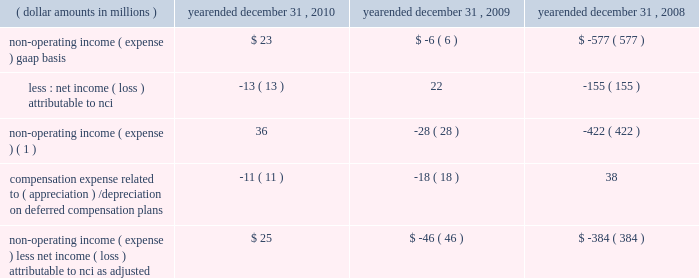4 4 m a n a g e m e n t 2019 s d i s c u s s i o n notes to table ( continued ) ( a ) ( continued ) management believes that operating income , as adjusted , and operating margin , as adjusted , are effective indicators of blackrock 2019s financial performance over time .
As such , management believes that operating income , as adjusted , and operating margin , as adjusted , provide useful disclosure to investors .
Operating income , as adjusted : bgi transaction and integration costs recorded in 2010 and 2009 consist principally of certain advisory payments , compensation expense , legal fees , marketing and promotional , occupancy and consulting expenses incurred in conjunction with the bgi transaction .
Restructuring charges recorded in 2009 and 2008 consist of compensation costs , occupancy costs and professional fees .
The expenses associated with restructuring and bgi transaction and integration costs have been deemed non-recurring by management and have been excluded from operating income , as adjusted , to help enhance the comparability of this information to the current reporting periods .
As such , management believes that operating margins exclusive of these costs are useful measures in evaluating blackrock 2019s operating performance for the respective periods .
The portion of compensation expense associated with certain long-term incentive plans ( 201cltip 201d ) that will be funded through the distribution to participants of shares of blackrock stock held by pnc and a merrill lynch cash compensation contribution , a portion of which has been received , have been excluded because these charges ultimately do not impact blackrock 2019s book value .
Compensation expense associated with appreciation/ ( depreciation ) on investments related to certain blackrock deferred compensation plans has been excluded as returns on investments set aside for these plans , which substantially offset this expense , are reported in non-operating income ( expense ) .
Operating margin , as adjusted : operating income used for measuring operating margin , as adjusted , is equal to operating income , as adjusted , excluding the impact of closed-end fund launch costs and commissions .
Management believes that excluding such costs and commissions is useful because these costs can fluctuate considerably and revenues associated with the expenditure of these costs will not fully impact the company 2019s results until future periods .
Operating margin , as adjusted , allows the company to compare performance from period-to-period by adjusting for items that may not recur , recur infrequently or may fluctuate based on market movements , such as restructuring charges , transaction and integration costs , closed-end fund launch costs , commissions paid to certain employees as compensation and fluctua- tions in compensation expense based on mark-to-market movements in investments held to fund certain compensation plans .
The company also uses operating margin , as adjusted , to monitor corporate performance and efficiency and as a benchmark to compare its performance to other companies .
Management uses both the gaap and non-gaap financial measures in evaluating the financial performance of blackrock .
The non-gaap measure by itself may pose limitations because it does not include all of the company 2019s revenues and expenses .
Revenue used for operating margin , as adjusted , excludes distribution and servicing costs paid to related parties and other third parties .
Management believes that excluding such costs is useful to blackrock because it creates consistency in the treatment for certain contracts for similar services , which due to the terms of the contracts , are accounted for under gaap on a net basis within investment advisory , administration fees and securities lending revenue .
Amortization of deferred sales commissions is excluded from revenue used for operating margin measurement , as adjusted , because such costs , over time , offset distribution fee revenue earned by the company .
Reimbursable property management compensation represented com- pensation and benefits paid to personnel of metric property management , inc .
( 201cmetric 201d ) , a subsidiary of blackrock realty advisors , inc .
( 201crealty 201d ) .
Prior to the transfer in 2008 , these employees were retained on metric 2019s payroll when certain properties were acquired by realty 2019s clients .
The related compensation and benefits were fully reimbursed by realty 2019s clients and have been excluded from revenue used for operating margin , as adjusted , because they did not bear an economic cost to blackrock .
For each of these items , blackrock excludes from revenue used for operating margin , as adjusted , the costs related to each of these items as a proxy for such offsetting revenues .
( b ) non-operating income ( expense ) , less net income ( loss ) attributable to non-controlling interests , as adjusted : non-operating income ( expense ) , less net income ( loss ) attributable to non-controlling interests ( 201cnci 201d ) , as adjusted , equals non-operating income ( expense ) , gaap basis , less net income ( loss ) attributable to nci , gaap basis , adjusted for compensation expense associated with depreciation/ ( appreciation ) on investments related to certain blackrock deferred compensation plans .
The compensation expense offset is recorded in operating income .
This compensation expense has been included in non-operating income ( expense ) , less net income ( loss ) attributable to nci , as adjusted , to offset returns on investments set aside for these plans , which are reported in non-operating income ( expense ) , gaap basis. .
Non-operating income ( expense ) ( 1 ) 36 ( 28 ) ( 422 ) compensation expense related to ( appreciation ) / depreciation on deferred compensation plans ( 11 ) ( 18 ) 38 non-operating income ( expense ) , less net income ( loss ) attributable to nci , as adjusted $ 25 ( $ 46 ) ( $ 384 ) ( 1 ) net of net income ( loss ) attributable to non-controlling interests .
Management believes that non-operating income ( expense ) , less net income ( loss ) attributable to nci , as adjusted , provides for comparability of this information to prior periods and is an effective measure for reviewing blackrock 2019s non-operating contribution to its results .
As compensation expense associated with ( appreciation ) /depreciation on investments related to certain deferred compensation plans , which is included in operating income , offsets the gain/ ( loss ) on the investments set aside for these plans , management believes that non-operating income ( expense ) , less net income ( loss ) attributable to nci , as adjusted , provides a useful measure , for both management and investors , of blackrock 2019s non-operating results that impact book value. .
What is the net change in non-operating income from 2009 to 2010? 
Computations: (36 - -28)
Answer: 64.0. 